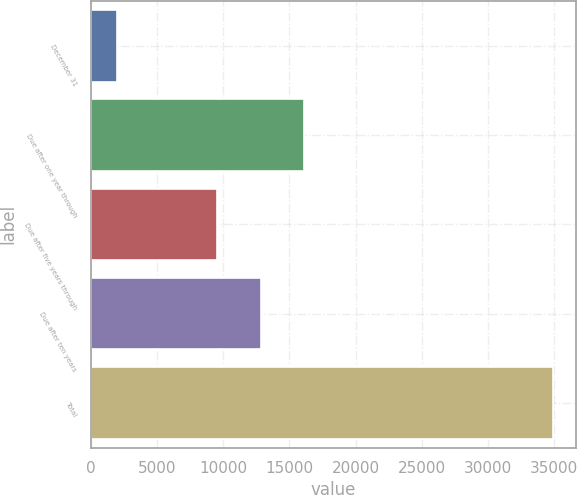Convert chart to OTSL. <chart><loc_0><loc_0><loc_500><loc_500><bar_chart><fcel>December 31<fcel>Due after one year through<fcel>Due after five years through<fcel>Due after ten years<fcel>Total<nl><fcel>2006<fcel>16140.2<fcel>9555<fcel>12847.6<fcel>34932<nl></chart> 